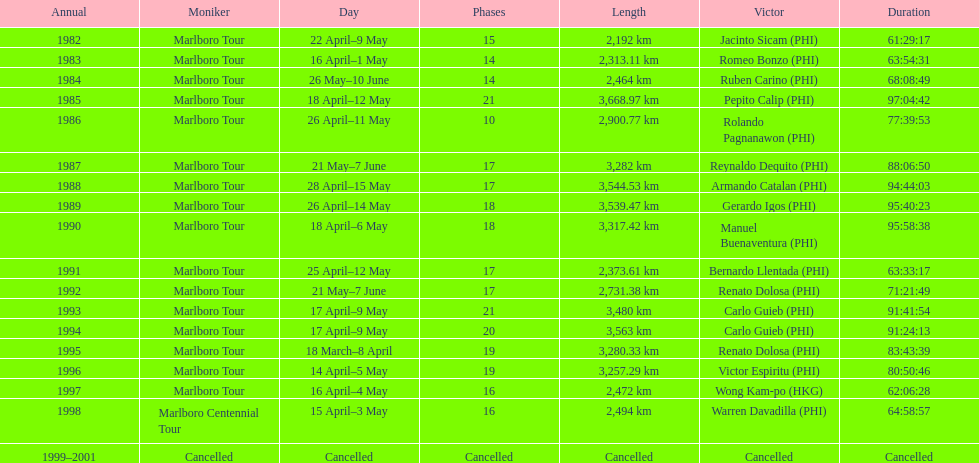What was the largest distance traveled for the marlboro tour? 3,668.97 km. 